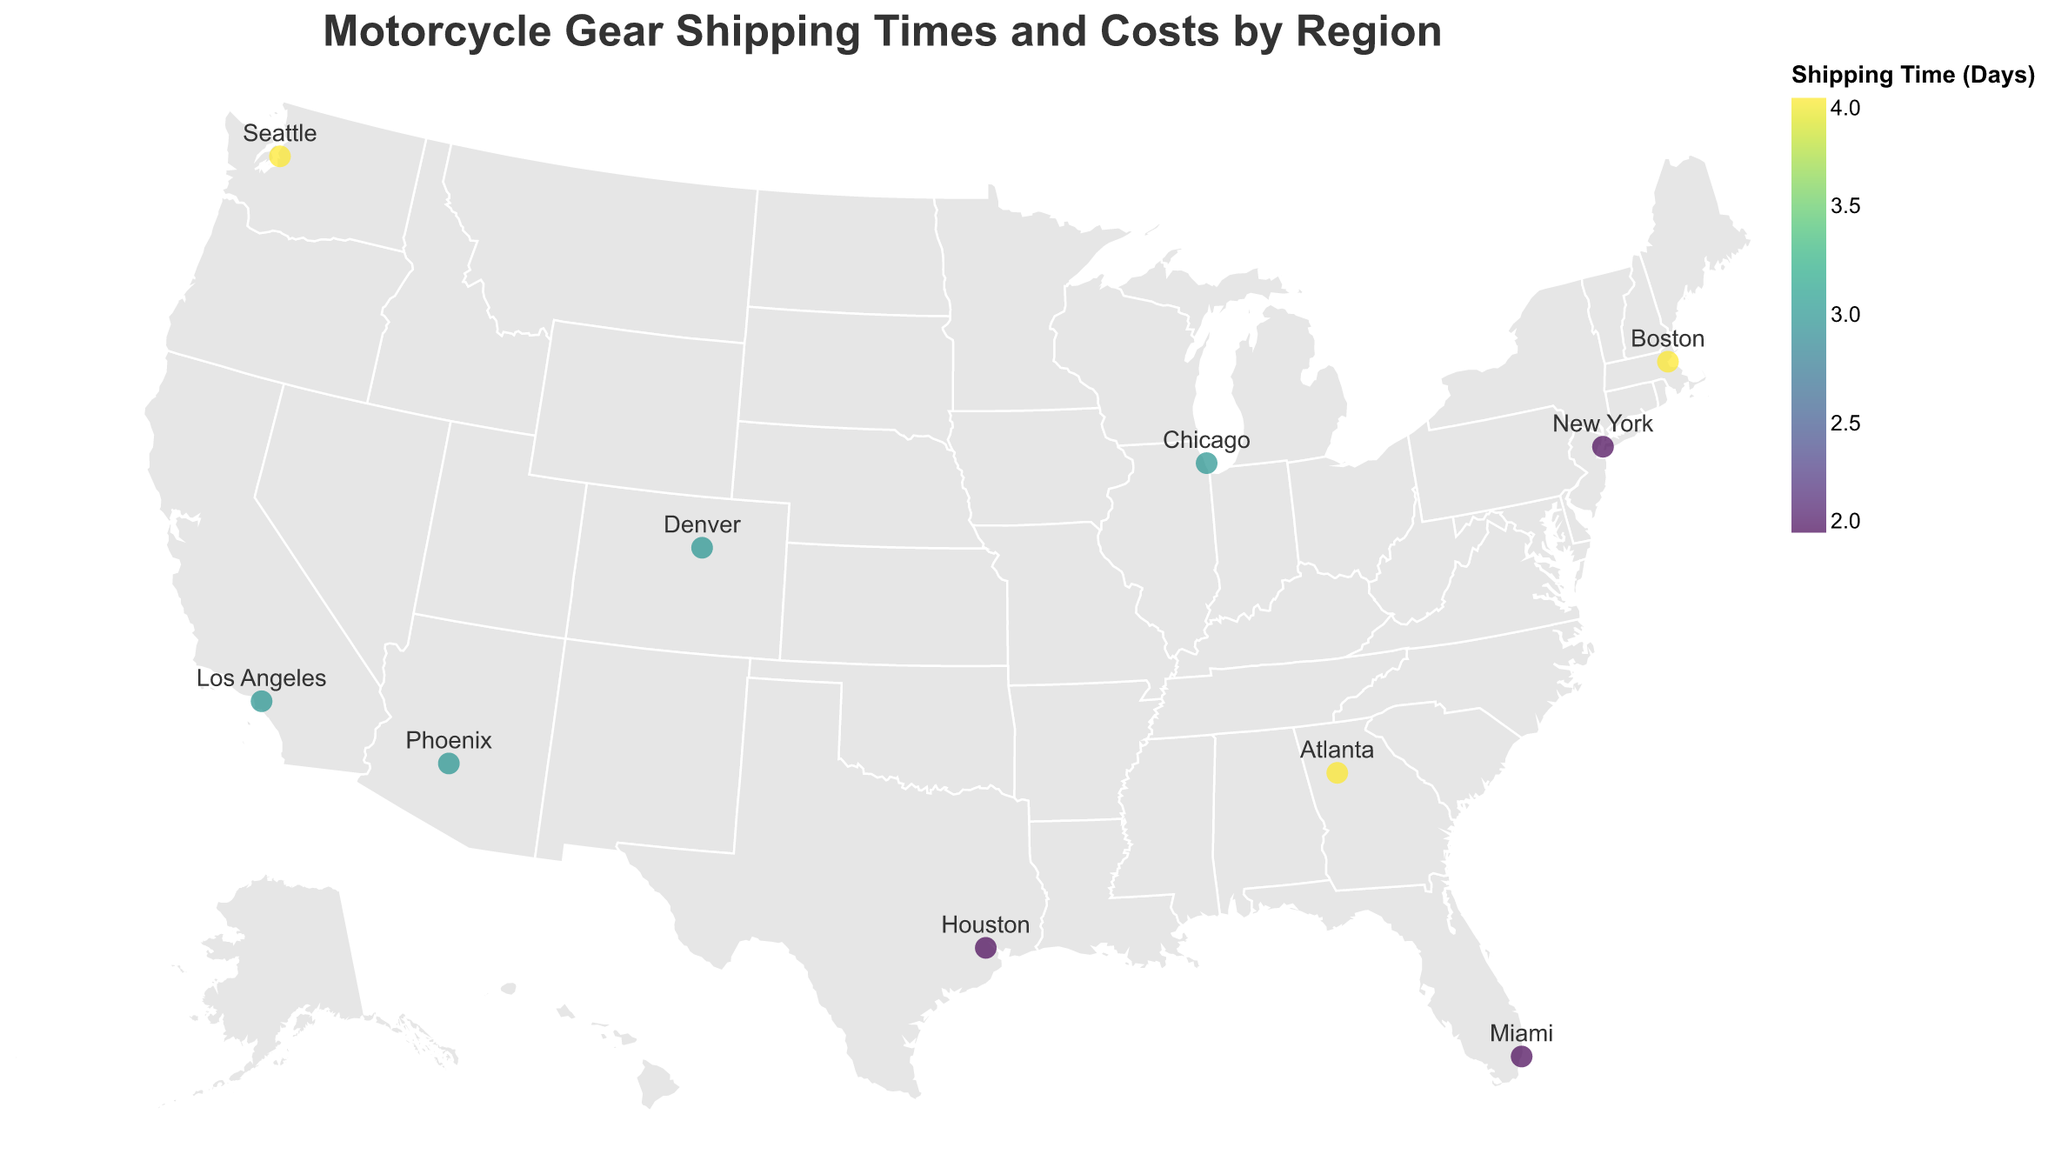How many regions have a shipping time of 4 days? Count the number of regions with a shipping time of 4 days by looking at the legend and the colors associated with 4 days in the plot: Seattle, Atlanta, and Boston. This gives us 3 regions.
Answer: 3 Which region has the highest shipping cost? Compare the shipping costs across all the regions by looking at the tooltips or perhaps focusing on the darker color in the scale representing the highest values. Boston has the highest shipping cost at $23.99.
Answer: Boston Which regions have the minimum shipping time, and what is that shipping time? Identify the regions with the lowest color value in the plot. New York, Houston, and Miami all have the minimum shipping time of 2 days.
Answer: New York, Houston, Miami (2 days) What is the average shipping cost for regions with a shipping time of 3 days? List the shipping costs for regions with 3 days of shipping time: Los Angeles ($19.99), Chicago ($17.99), Denver ($18.99), Phoenix ($20.99). Calculate the average: (19.99 + 17.99 + 18.99 + 20.99) / 4 = 19.24.
Answer: $19.24 Which region is served by the RevZilla (Philadelphia) distribution center? Look at the tooltip or label near the point representing RevZilla (Philadelphia), which corresponds to New York.
Answer: New York Compare the shipping costs between Seattle and Phoenix. Which one is higher and by how much? Identify the shipping costs for Seattle ($22.99) and Phoenix ($20.99) using the plot. Calculate the difference: $22.99 - $20.99 = $2.00. Seattle has the higher cost by $2.00.
Answer: Seattle, $2.00 What is the difference in shipping times between Atlanta and Houston? Determine the shipping times for Atlanta (4 days) and Houston (2 days) from the figure. The difference is 4 - 2 = 2 days.
Answer: 2 days Which region has the longest shipping time, and what is that time? Identify the highest shipping time by examining the color scale and finding the region with the largest value. Seattle, Atlanta, and Boston each have the longest shipping time of 4 days.
Answer: Seattle, Atlanta, Boston (4 days) From which distribution center is the Chicago region served, and what is its shipping cost? Identify the point labeled “Chicago” and refer to the tooltip for Shipping Cost and Distribution Center. Chicago is served by J&P Cycles (Daytona Beach) at a cost of $17.99.
Answer: J&P Cycles (Daytona Beach), $17.99 